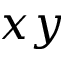Convert formula to latex. <formula><loc_0><loc_0><loc_500><loc_500>x y</formula> 